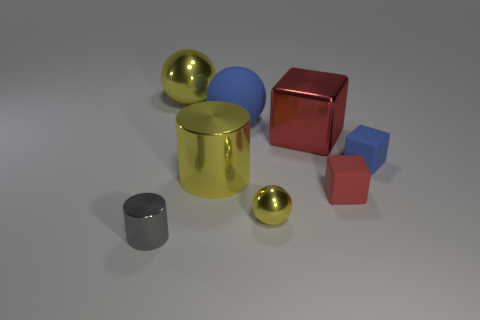Subtract all small yellow spheres. How many spheres are left? 2 Add 1 tiny yellow metal spheres. How many objects exist? 9 Add 6 large metallic blocks. How many large metallic blocks are left? 7 Add 1 small cylinders. How many small cylinders exist? 2 Subtract all gray cylinders. How many cylinders are left? 1 Subtract 0 cyan balls. How many objects are left? 8 Subtract all spheres. How many objects are left? 5 Subtract 3 spheres. How many spheres are left? 0 Subtract all blue balls. Subtract all yellow blocks. How many balls are left? 2 Subtract all green blocks. How many yellow balls are left? 2 